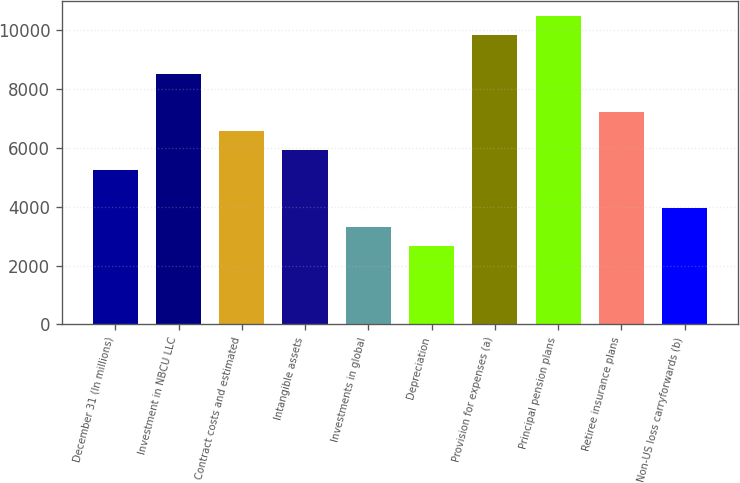Convert chart. <chart><loc_0><loc_0><loc_500><loc_500><bar_chart><fcel>December 31 (In millions)<fcel>Investment in NBCU LLC<fcel>Contract costs and estimated<fcel>Intangible assets<fcel>Investments in global<fcel>Depreciation<fcel>Provision for expenses (a)<fcel>Principal pension plans<fcel>Retiree insurance plans<fcel>Non-US loss carryforwards (b)<nl><fcel>5262.8<fcel>8523.3<fcel>6567<fcel>5914.9<fcel>3306.5<fcel>2654.4<fcel>9827.5<fcel>10479.6<fcel>7219.1<fcel>3958.6<nl></chart> 